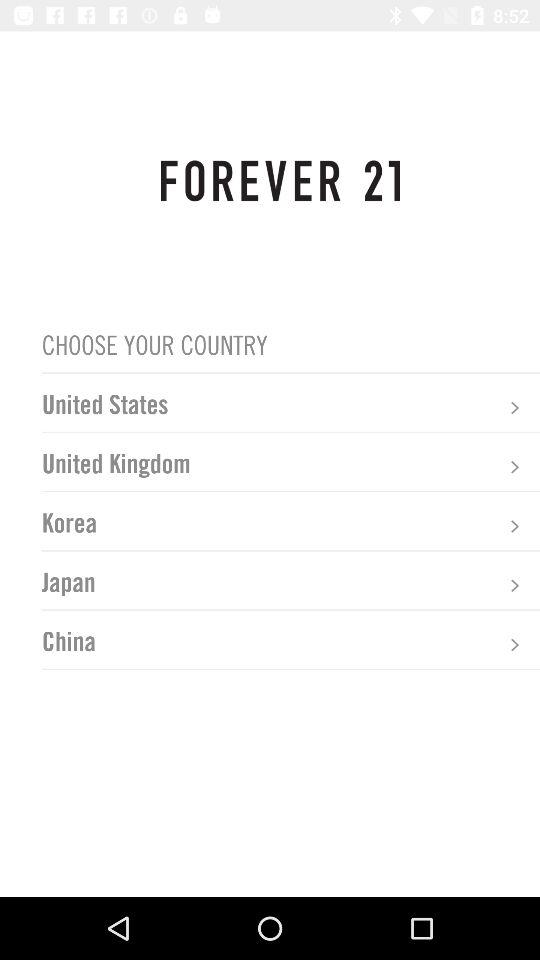What is the application name? The application name is "FOREVER 21". 